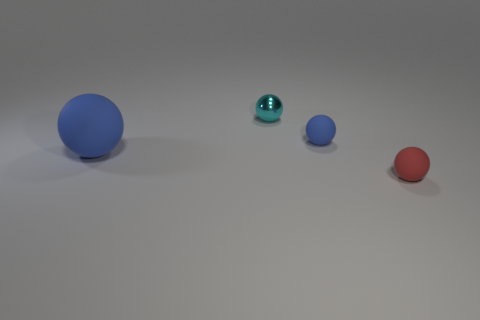Add 4 green things. How many objects exist? 8 Subtract all brown shiny cubes. Subtract all small cyan metallic spheres. How many objects are left? 3 Add 3 tiny cyan metal balls. How many tiny cyan metal balls are left? 4 Add 2 big cyan matte blocks. How many big cyan matte blocks exist? 2 Subtract 0 yellow cubes. How many objects are left? 4 